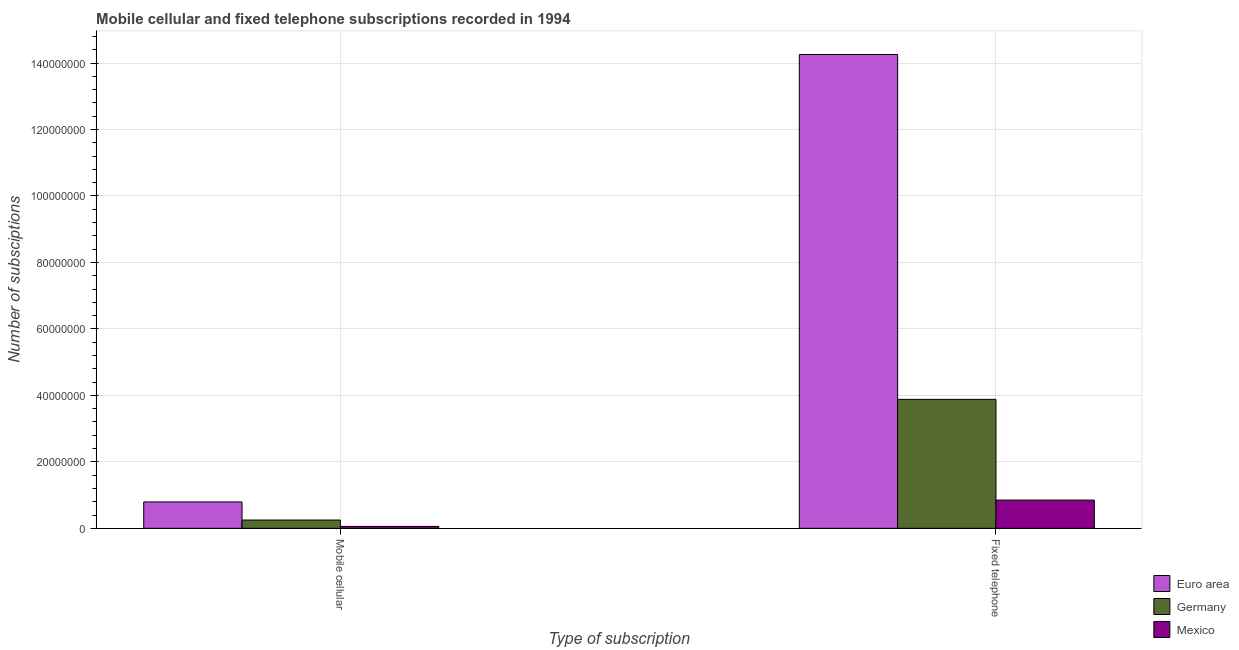How many groups of bars are there?
Give a very brief answer. 2. Are the number of bars on each tick of the X-axis equal?
Ensure brevity in your answer.  Yes. What is the label of the 1st group of bars from the left?
Provide a succinct answer. Mobile cellular. What is the number of mobile cellular subscriptions in Euro area?
Your answer should be very brief. 7.94e+06. Across all countries, what is the maximum number of fixed telephone subscriptions?
Provide a succinct answer. 1.43e+08. Across all countries, what is the minimum number of mobile cellular subscriptions?
Provide a succinct answer. 5.69e+05. What is the total number of mobile cellular subscriptions in the graph?
Your answer should be very brief. 1.10e+07. What is the difference between the number of mobile cellular subscriptions in Mexico and that in Euro area?
Your answer should be very brief. -7.37e+06. What is the difference between the number of fixed telephone subscriptions in Mexico and the number of mobile cellular subscriptions in Euro area?
Keep it short and to the point. 5.57e+05. What is the average number of mobile cellular subscriptions per country?
Ensure brevity in your answer.  3.66e+06. What is the difference between the number of fixed telephone subscriptions and number of mobile cellular subscriptions in Germany?
Make the answer very short. 3.63e+07. What is the ratio of the number of fixed telephone subscriptions in Euro area to that in Germany?
Your answer should be compact. 3.67. Is the number of mobile cellular subscriptions in Mexico less than that in Germany?
Provide a short and direct response. Yes. What does the 1st bar from the left in Mobile cellular represents?
Your answer should be compact. Euro area. What does the 2nd bar from the right in Fixed telephone represents?
Make the answer very short. Germany. How many bars are there?
Offer a very short reply. 6. Are all the bars in the graph horizontal?
Keep it short and to the point. No. How many countries are there in the graph?
Provide a succinct answer. 3. What is the difference between two consecutive major ticks on the Y-axis?
Keep it short and to the point. 2.00e+07. Are the values on the major ticks of Y-axis written in scientific E-notation?
Provide a succinct answer. No. Does the graph contain grids?
Provide a succinct answer. Yes. Where does the legend appear in the graph?
Keep it short and to the point. Bottom right. How many legend labels are there?
Your response must be concise. 3. What is the title of the graph?
Keep it short and to the point. Mobile cellular and fixed telephone subscriptions recorded in 1994. What is the label or title of the X-axis?
Give a very brief answer. Type of subscription. What is the label or title of the Y-axis?
Give a very brief answer. Number of subsciptions. What is the Number of subsciptions of Euro area in Mobile cellular?
Offer a very short reply. 7.94e+06. What is the Number of subsciptions of Germany in Mobile cellular?
Keep it short and to the point. 2.49e+06. What is the Number of subsciptions of Mexico in Mobile cellular?
Provide a succinct answer. 5.69e+05. What is the Number of subsciptions in Euro area in Fixed telephone?
Ensure brevity in your answer.  1.43e+08. What is the Number of subsciptions of Germany in Fixed telephone?
Your answer should be compact. 3.88e+07. What is the Number of subsciptions in Mexico in Fixed telephone?
Keep it short and to the point. 8.49e+06. Across all Type of subscription, what is the maximum Number of subsciptions in Euro area?
Offer a terse response. 1.43e+08. Across all Type of subscription, what is the maximum Number of subsciptions in Germany?
Your answer should be compact. 3.88e+07. Across all Type of subscription, what is the maximum Number of subsciptions of Mexico?
Provide a short and direct response. 8.49e+06. Across all Type of subscription, what is the minimum Number of subsciptions of Euro area?
Your answer should be compact. 7.94e+06. Across all Type of subscription, what is the minimum Number of subsciptions in Germany?
Provide a short and direct response. 2.49e+06. Across all Type of subscription, what is the minimum Number of subsciptions in Mexico?
Make the answer very short. 5.69e+05. What is the total Number of subsciptions in Euro area in the graph?
Make the answer very short. 1.50e+08. What is the total Number of subsciptions of Germany in the graph?
Offer a very short reply. 4.13e+07. What is the total Number of subsciptions in Mexico in the graph?
Provide a short and direct response. 9.06e+06. What is the difference between the Number of subsciptions in Euro area in Mobile cellular and that in Fixed telephone?
Offer a very short reply. -1.35e+08. What is the difference between the Number of subsciptions of Germany in Mobile cellular and that in Fixed telephone?
Provide a short and direct response. -3.63e+07. What is the difference between the Number of subsciptions in Mexico in Mobile cellular and that in Fixed telephone?
Your response must be concise. -7.92e+06. What is the difference between the Number of subsciptions of Euro area in Mobile cellular and the Number of subsciptions of Germany in Fixed telephone?
Offer a very short reply. -3.09e+07. What is the difference between the Number of subsciptions of Euro area in Mobile cellular and the Number of subsciptions of Mexico in Fixed telephone?
Ensure brevity in your answer.  -5.57e+05. What is the difference between the Number of subsciptions in Germany in Mobile cellular and the Number of subsciptions in Mexico in Fixed telephone?
Your answer should be compact. -6.00e+06. What is the average Number of subsciptions in Euro area per Type of subscription?
Your answer should be very brief. 7.52e+07. What is the average Number of subsciptions in Germany per Type of subscription?
Your response must be concise. 2.06e+07. What is the average Number of subsciptions of Mexico per Type of subscription?
Your answer should be very brief. 4.53e+06. What is the difference between the Number of subsciptions in Euro area and Number of subsciptions in Germany in Mobile cellular?
Keep it short and to the point. 5.44e+06. What is the difference between the Number of subsciptions of Euro area and Number of subsciptions of Mexico in Mobile cellular?
Offer a very short reply. 7.37e+06. What is the difference between the Number of subsciptions of Germany and Number of subsciptions of Mexico in Mobile cellular?
Provide a succinct answer. 1.92e+06. What is the difference between the Number of subsciptions in Euro area and Number of subsciptions in Germany in Fixed telephone?
Your answer should be very brief. 1.04e+08. What is the difference between the Number of subsciptions of Euro area and Number of subsciptions of Mexico in Fixed telephone?
Offer a terse response. 1.34e+08. What is the difference between the Number of subsciptions in Germany and Number of subsciptions in Mexico in Fixed telephone?
Make the answer very short. 3.03e+07. What is the ratio of the Number of subsciptions of Euro area in Mobile cellular to that in Fixed telephone?
Your answer should be very brief. 0.06. What is the ratio of the Number of subsciptions in Germany in Mobile cellular to that in Fixed telephone?
Provide a short and direct response. 0.06. What is the ratio of the Number of subsciptions in Mexico in Mobile cellular to that in Fixed telephone?
Give a very brief answer. 0.07. What is the difference between the highest and the second highest Number of subsciptions in Euro area?
Your response must be concise. 1.35e+08. What is the difference between the highest and the second highest Number of subsciptions of Germany?
Offer a terse response. 3.63e+07. What is the difference between the highest and the second highest Number of subsciptions in Mexico?
Ensure brevity in your answer.  7.92e+06. What is the difference between the highest and the lowest Number of subsciptions of Euro area?
Your response must be concise. 1.35e+08. What is the difference between the highest and the lowest Number of subsciptions of Germany?
Your answer should be very brief. 3.63e+07. What is the difference between the highest and the lowest Number of subsciptions in Mexico?
Offer a very short reply. 7.92e+06. 